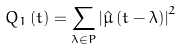<formula> <loc_0><loc_0><loc_500><loc_500>Q _ { 1 } \left ( t \right ) = \sum _ { \lambda \in P } \left | \hat { \mu } \left ( t - \lambda \right ) \right | ^ { 2 }</formula> 